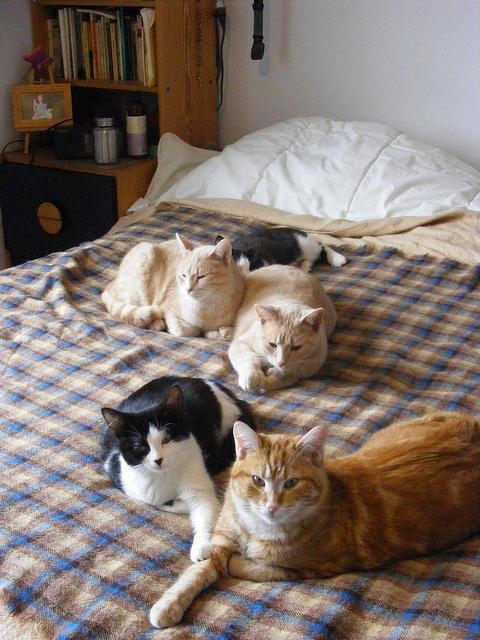How many cats are on the bed?
Give a very brief answer. 5. How many cats can you see?
Give a very brief answer. 5. How many people are holding a camera?
Give a very brief answer. 0. 